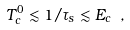Convert formula to latex. <formula><loc_0><loc_0><loc_500><loc_500>T _ { c } ^ { 0 } \lesssim 1 / \tau _ { s } \lesssim E _ { c } \ ,</formula> 